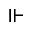Convert formula to latex. <formula><loc_0><loc_0><loc_500><loc_500>\ V d a s h</formula> 